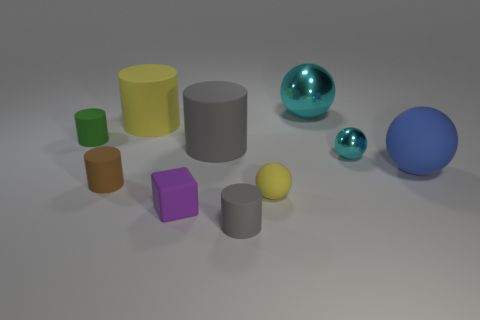Subtract all brown cylinders. How many cylinders are left? 4 Subtract 1 cylinders. How many cylinders are left? 4 Subtract all gray cylinders. How many cylinders are left? 3 Subtract all brown balls. Subtract all yellow cylinders. How many balls are left? 4 Subtract all spheres. How many objects are left? 6 Subtract all tiny cyan cubes. Subtract all big cyan things. How many objects are left? 9 Add 1 green cylinders. How many green cylinders are left? 2 Add 4 red shiny balls. How many red shiny balls exist? 4 Subtract 0 gray blocks. How many objects are left? 10 